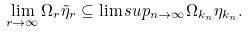Convert formula to latex. <formula><loc_0><loc_0><loc_500><loc_500>\lim _ { r \to \infty } \Omega _ { r } \tilde { \eta } _ { r } \subseteq \lim s u p _ { n \to \infty } \Omega _ { k _ { n } } \eta _ { k _ { n } } .</formula> 